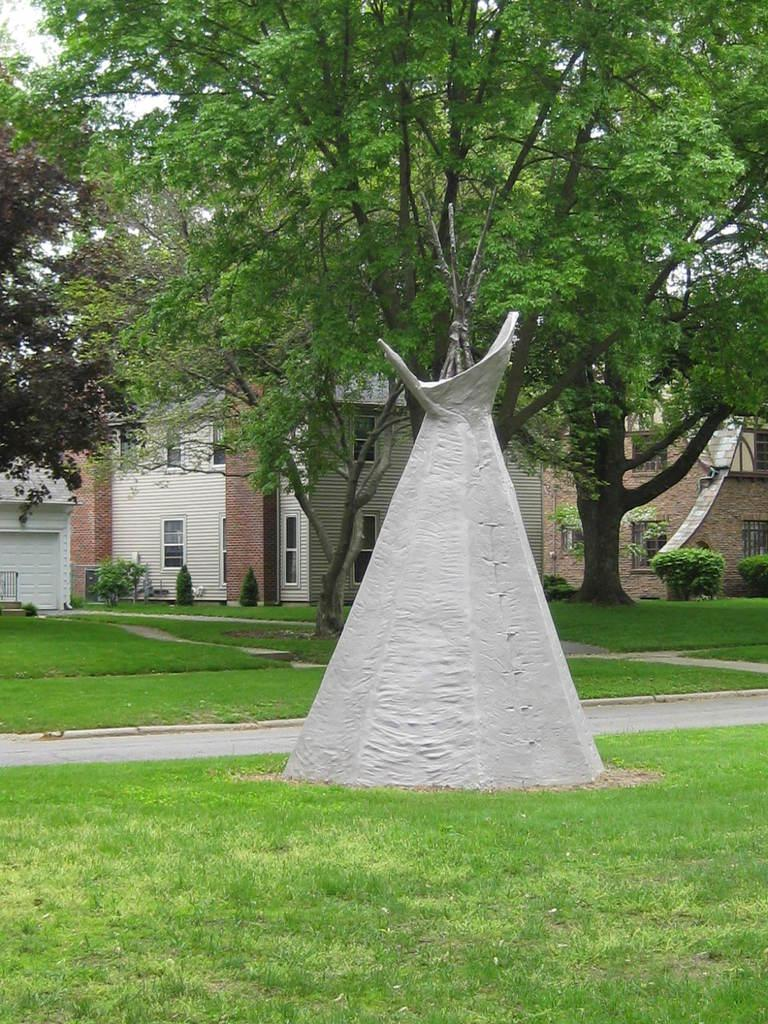What type of vegetation is at the bottom of the image? There is grass at the bottom of the image. What can be seen in the middle of the image? There are trees and plants in the middle of the image. What type of structures are visible in the background of the image? There are buildings in the background of the image. What is visible at the top of the image? The sky is visible at the top of the image. What is the number of inventions visible in the image? There are no inventions present in the image. Can you hear the plants crying in the image? Plants do not have the ability to cry, and there are no sounds depicted in the image. 